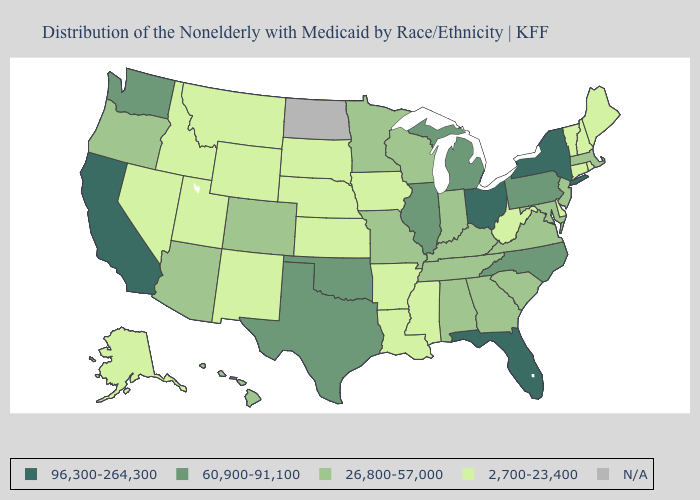Which states hav the highest value in the West?
Quick response, please. California. What is the lowest value in states that border Utah?
Quick response, please. 2,700-23,400. What is the value of Mississippi?
Keep it brief. 2,700-23,400. Does New Hampshire have the highest value in the USA?
Keep it brief. No. Name the states that have a value in the range 26,800-57,000?
Keep it brief. Alabama, Arizona, Colorado, Georgia, Hawaii, Indiana, Kentucky, Maryland, Massachusetts, Minnesota, Missouri, New Jersey, Oregon, South Carolina, Tennessee, Virginia, Wisconsin. Does Colorado have the highest value in the West?
Short answer required. No. Which states have the lowest value in the West?
Answer briefly. Alaska, Idaho, Montana, Nevada, New Mexico, Utah, Wyoming. What is the lowest value in the USA?
Write a very short answer. 2,700-23,400. What is the value of Kentucky?
Be succinct. 26,800-57,000. Is the legend a continuous bar?
Write a very short answer. No. What is the value of Mississippi?
Be succinct. 2,700-23,400. How many symbols are there in the legend?
Answer briefly. 5. What is the value of Ohio?
Short answer required. 96,300-264,300. Among the states that border New Hampshire , does Massachusetts have the lowest value?
Write a very short answer. No. 